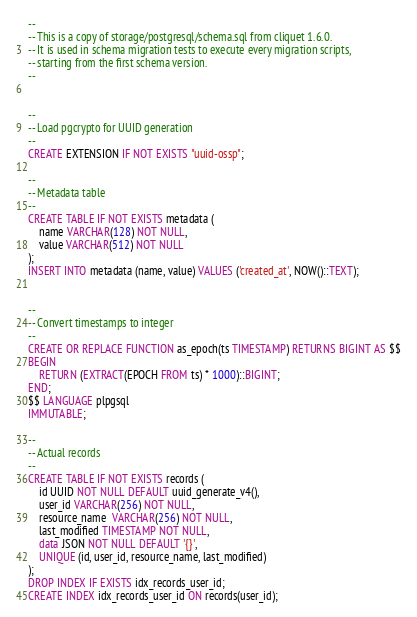<code> <loc_0><loc_0><loc_500><loc_500><_SQL_>--
-- This is a copy of storage/postgresql/schema.sql from cliquet 1.6.0.
-- It is used in schema migration tests to execute every migration scripts,
-- starting from the first schema version.
--


--
-- Load pgcrypto for UUID generation
--
CREATE EXTENSION IF NOT EXISTS "uuid-ossp";

--
-- Metadata table
--
CREATE TABLE IF NOT EXISTS metadata (
    name VARCHAR(128) NOT NULL,
    value VARCHAR(512) NOT NULL
);
INSERT INTO metadata (name, value) VALUES ('created_at', NOW()::TEXT);


--
-- Convert timestamps to integer
--
CREATE OR REPLACE FUNCTION as_epoch(ts TIMESTAMP) RETURNS BIGINT AS $$
BEGIN
    RETURN (EXTRACT(EPOCH FROM ts) * 1000)::BIGINT;
END;
$$ LANGUAGE plpgsql
IMMUTABLE;

--
-- Actual records
--
CREATE TABLE IF NOT EXISTS records (
    id UUID NOT NULL DEFAULT uuid_generate_v4(),
    user_id VARCHAR(256) NOT NULL,
    resource_name  VARCHAR(256) NOT NULL,
    last_modified TIMESTAMP NOT NULL,
    data JSON NOT NULL DEFAULT '{}',
    UNIQUE (id, user_id, resource_name, last_modified)
);
DROP INDEX IF EXISTS idx_records_user_id;
CREATE INDEX idx_records_user_id ON records(user_id);</code> 